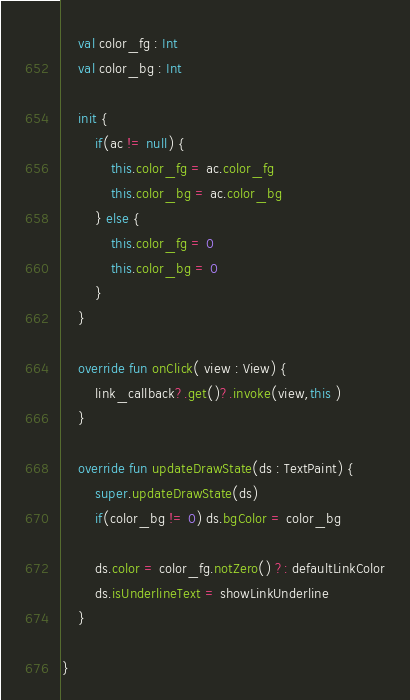<code> <loc_0><loc_0><loc_500><loc_500><_Kotlin_>
	val color_fg : Int
	val color_bg : Int
	
	init {
		if(ac != null) {
			this.color_fg = ac.color_fg
			this.color_bg = ac.color_bg
		} else {
			this.color_fg = 0
			this.color_bg = 0
		}
	}
	
	override fun onClick( view : View) {
		link_callback?.get()?.invoke(view,this )
	}
	
	override fun updateDrawState(ds : TextPaint) {
		super.updateDrawState(ds)
		if(color_bg != 0) ds.bgColor = color_bg
		
		ds.color = color_fg.notZero() ?: defaultLinkColor
		ds.isUnderlineText = showLinkUnderline
	}
	
}
</code> 